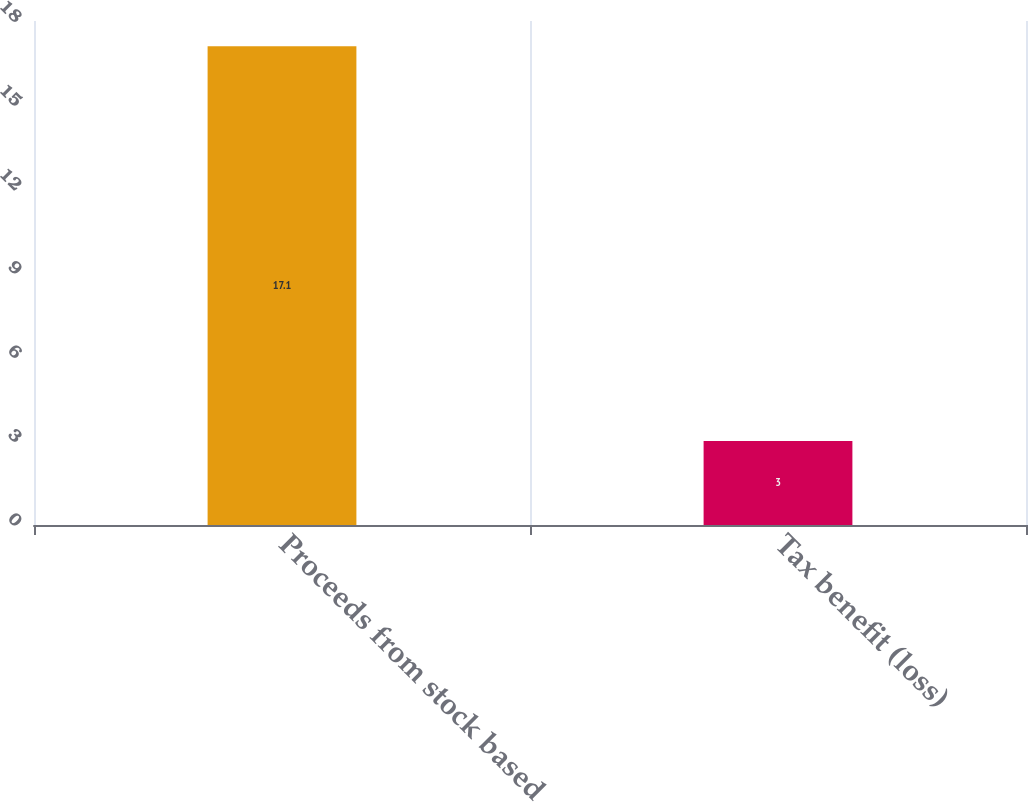<chart> <loc_0><loc_0><loc_500><loc_500><bar_chart><fcel>Proceeds from stock based<fcel>Tax benefit (loss)<nl><fcel>17.1<fcel>3<nl></chart> 